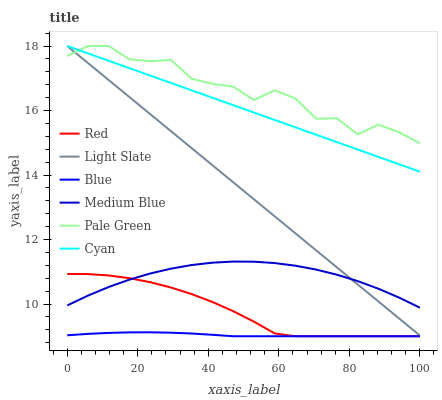Does Blue have the minimum area under the curve?
Answer yes or no. Yes. Does Pale Green have the maximum area under the curve?
Answer yes or no. Yes. Does Light Slate have the minimum area under the curve?
Answer yes or no. No. Does Light Slate have the maximum area under the curve?
Answer yes or no. No. Is Light Slate the smoothest?
Answer yes or no. Yes. Is Pale Green the roughest?
Answer yes or no. Yes. Is Medium Blue the smoothest?
Answer yes or no. No. Is Medium Blue the roughest?
Answer yes or no. No. Does Blue have the lowest value?
Answer yes or no. Yes. Does Light Slate have the lowest value?
Answer yes or no. No. Does Cyan have the highest value?
Answer yes or no. Yes. Does Medium Blue have the highest value?
Answer yes or no. No. Is Red less than Pale Green?
Answer yes or no. Yes. Is Cyan greater than Red?
Answer yes or no. Yes. Does Pale Green intersect Light Slate?
Answer yes or no. Yes. Is Pale Green less than Light Slate?
Answer yes or no. No. Is Pale Green greater than Light Slate?
Answer yes or no. No. Does Red intersect Pale Green?
Answer yes or no. No. 